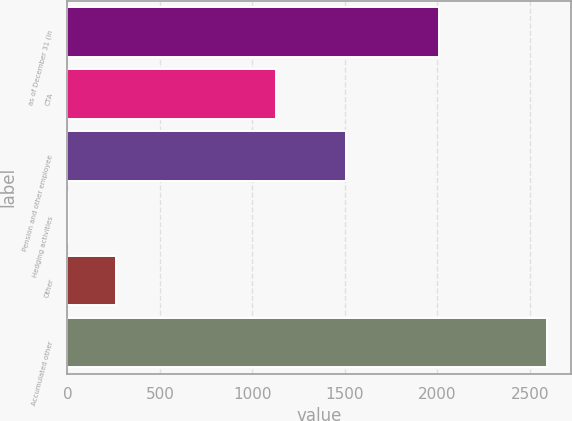Convert chart to OTSL. <chart><loc_0><loc_0><loc_500><loc_500><bar_chart><fcel>as of December 31 (in<fcel>CTA<fcel>Pension and other employee<fcel>Hedging activities<fcel>Other<fcel>Accumulated other<nl><fcel>2011<fcel>1129<fcel>1508<fcel>2<fcel>260.9<fcel>2591<nl></chart> 